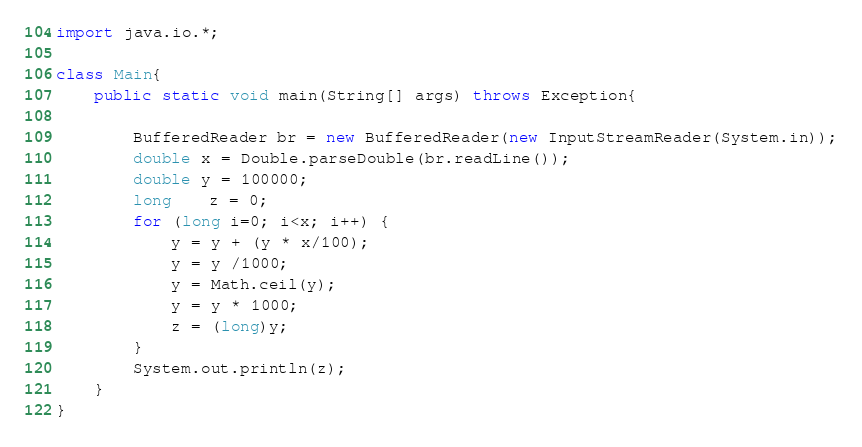<code> <loc_0><loc_0><loc_500><loc_500><_Java_>import java.io.*;
   
class Main{
    public static void main(String[] args) throws Exception{
         
        BufferedReader br = new BufferedReader(new InputStreamReader(System.in));
        double x = Double.parseDouble(br.readLine());
        double y = 100000;
        long    z = 0;
        for (long i=0; i<x; i++) {
            y = y + (y * x/100);
            y = y /1000;
            y = Math.ceil(y);
            y = y * 1000;
            z = (long)y;
        }
        System.out.println(z);
    }
}</code> 